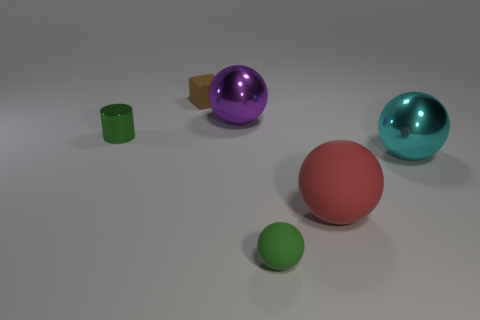Subtract all large cyan spheres. How many spheres are left? 3 Subtract all red balls. How many balls are left? 3 Subtract all cylinders. How many objects are left? 5 Add 2 tiny green matte objects. How many tiny green matte objects exist? 3 Add 3 large purple metallic objects. How many objects exist? 9 Subtract 1 green cylinders. How many objects are left? 5 Subtract all yellow balls. Subtract all brown cubes. How many balls are left? 4 Subtract all green blocks. How many brown balls are left? 0 Subtract all small metallic objects. Subtract all big spheres. How many objects are left? 2 Add 1 brown objects. How many brown objects are left? 2 